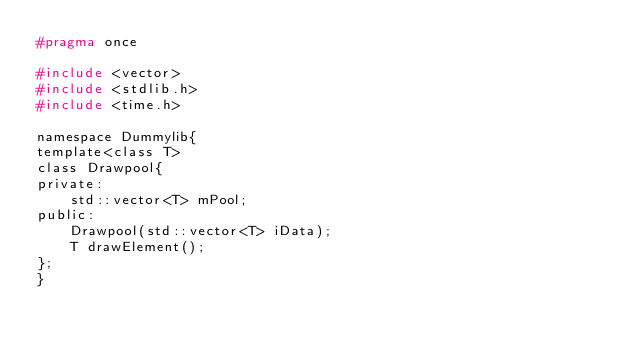Convert code to text. <code><loc_0><loc_0><loc_500><loc_500><_C_>#pragma once

#include <vector>
#include <stdlib.h>
#include <time.h>

namespace Dummylib{
template<class T>
class Drawpool{
private:
    std::vector<T> mPool;
public:
    Drawpool(std::vector<T> iData);
    T drawElement();
};
}
</code> 